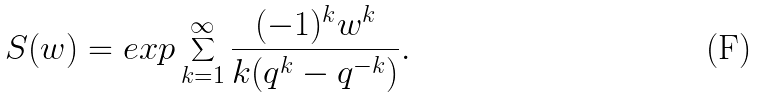Convert formula to latex. <formula><loc_0><loc_0><loc_500><loc_500>S ( w ) = e x p \sum _ { k = 1 } ^ { \infty } \frac { ( - 1 ) ^ { k } w ^ { k } } { k ( q ^ { k } - q ^ { - k } ) } .</formula> 